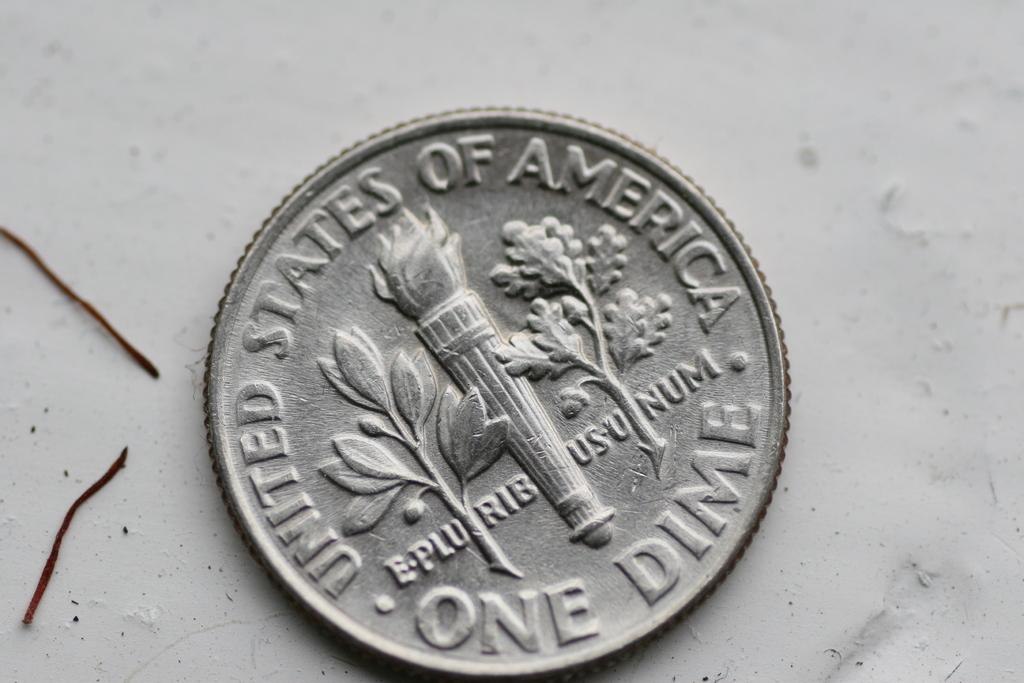<image>
Create a compact narrative representing the image presented. A dime from the united states of america is sitting on the ground. 